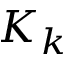Convert formula to latex. <formula><loc_0><loc_0><loc_500><loc_500>K _ { k }</formula> 